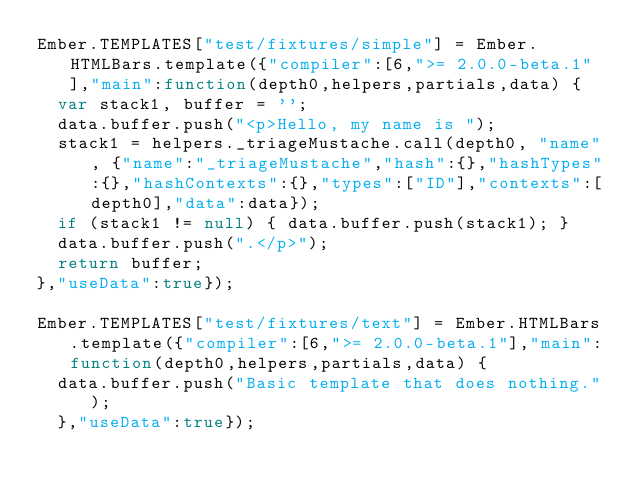Convert code to text. <code><loc_0><loc_0><loc_500><loc_500><_JavaScript_>Ember.TEMPLATES["test/fixtures/simple"] = Ember.HTMLBars.template({"compiler":[6,">= 2.0.0-beta.1"],"main":function(depth0,helpers,partials,data) {
  var stack1, buffer = '';
  data.buffer.push("<p>Hello, my name is ");
  stack1 = helpers._triageMustache.call(depth0, "name", {"name":"_triageMustache","hash":{},"hashTypes":{},"hashContexts":{},"types":["ID"],"contexts":[depth0],"data":data});
  if (stack1 != null) { data.buffer.push(stack1); }
  data.buffer.push(".</p>");
  return buffer;
},"useData":true});

Ember.TEMPLATES["test/fixtures/text"] = Ember.HTMLBars.template({"compiler":[6,">= 2.0.0-beta.1"],"main":function(depth0,helpers,partials,data) {
  data.buffer.push("Basic template that does nothing.");
  },"useData":true});</code> 